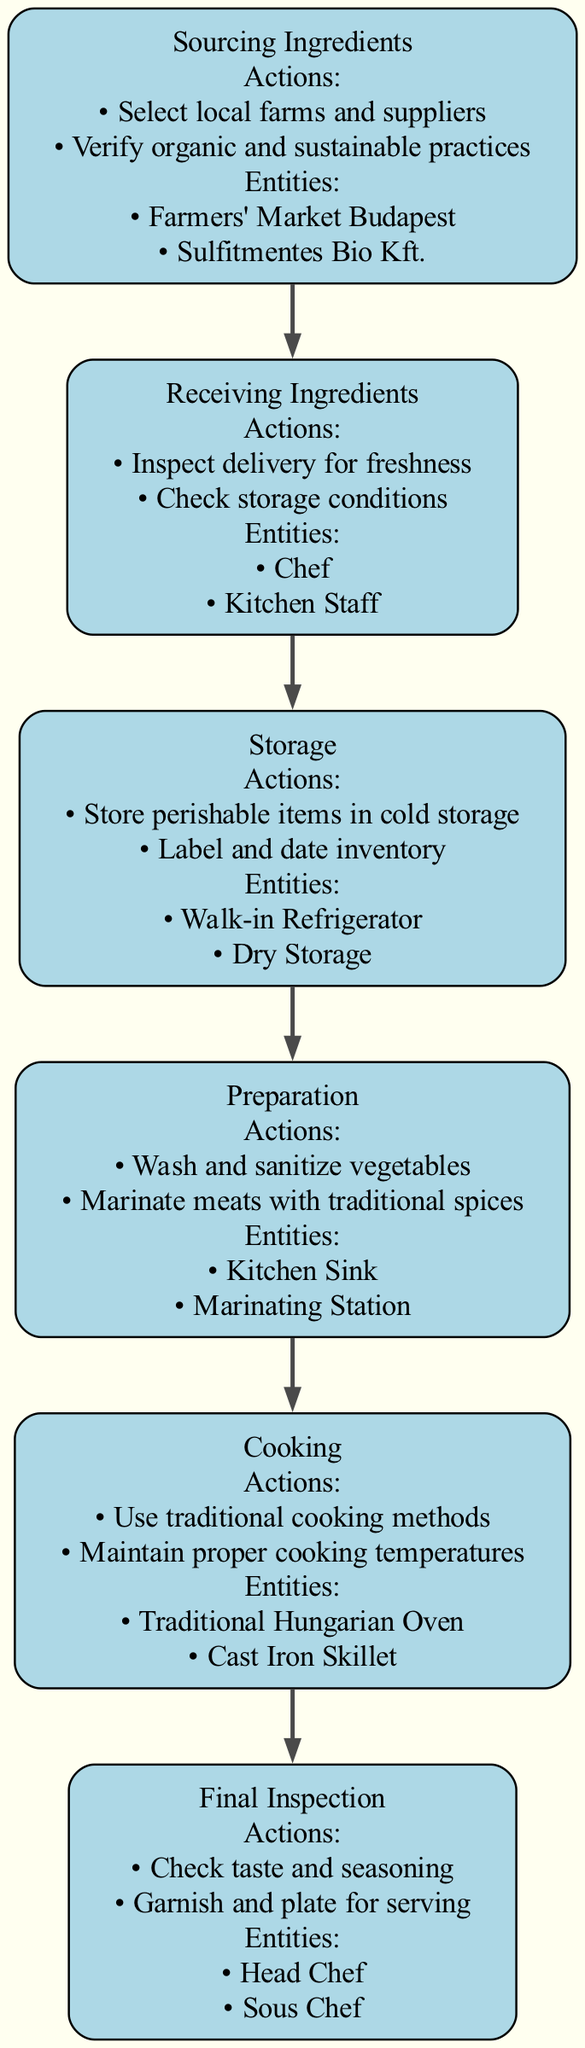What is the first step in the process flow? The first step in the process flow is explicitly labeled as "Sourcing Ingredients," which is the beginning of the Clinical Pathway.
Answer: Sourcing Ingredients How many actions are listed under the "Preparing Ingredients" step? The actions for the "Preparation" step are to "Wash and sanitize vegetables" and "Marinate meats with traditional spices," totaling two actions.
Answer: 2 What entities are involved in the "Receiving Ingredients" step? The entities under the "Receiving Ingredients" step include "Chef" and "Kitchen Staff," which are responsible for the inspection during this step.
Answer: Chef, Kitchen Staff What step follows "Storage"? Looking at the flow, the step that directly follows "Storage" is "Preparation," indicating the sequence of activities that must be undertaken.
Answer: Preparation Which step includes traditional cooking methods? "Cooking" is the step that mentions the use of traditional cooking methods, highlighting the importance of cultural practices in the cooking process.
Answer: Cooking How many steps are there in total within the Clinical Pathway? By counting the distinct steps provided in the diagram, we find that there are six steps in total.
Answer: 6 What action is required during the "Final Inspection" step? One of the actions mentioned for the "Final Inspection" step focuses on checking the taste and seasoning of the dish before serving.
Answer: Check taste and seasoning What storage method is used for perishable items? The diagram specifies that "Store perishable items in cold storage" as an essential action during the "Storage" step to ensure ingredient quality.
Answer: Cold storage Who is responsible for the final inspection along with the head chef? The "Sous Chef" is noted as a key entity involved in the "Final Inspection," working alongside the head chef in this crucial step.
Answer: Sous Chef 